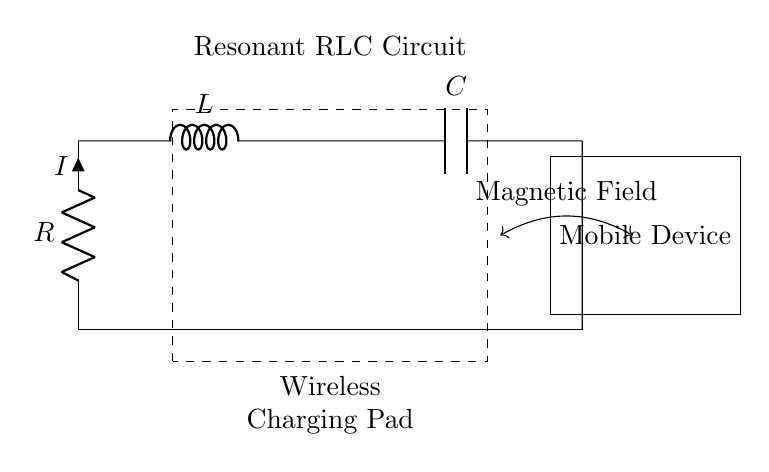What is the type of circuit shown? The circuit displayed is a resonant RLC circuit, indicated by the presence of a resistor, inductor, and capacitor arranged together.
Answer: resonant RLC circuit What components are present in the circuit? The circuit consists of three components: a resistor, an inductor, and a capacitor. Each component is labeled in the diagram.
Answer: resistor, inductor, capacitor What is the role of the magnetic field in this circuit? The magnetic field facilitates energy transfer between the resonant RLC circuit and the mobile device, which is essential for wireless charging.
Answer: energy transfer What connects the resonant RLC circuit to the mobile device? The connection is made through the magnetic field produced by the circuit, which enables the charging process for the mobile device.
Answer: magnetic field How many components are there in total? The total number of components in the circuit is three: one resistor, one inductor, and one capacitor. Counting them provides the total.
Answer: three What does the dashed rectangle represent? The dashed rectangle signifies the boundary of the wireless charging pad, indicating that the enclosed components work together for charging functionality.
Answer: wireless charging pad What is the current in the circuit denoted as? The current in the circuit is denoted by the symbol "I," which is labeled next to the resistor.
Answer: I 